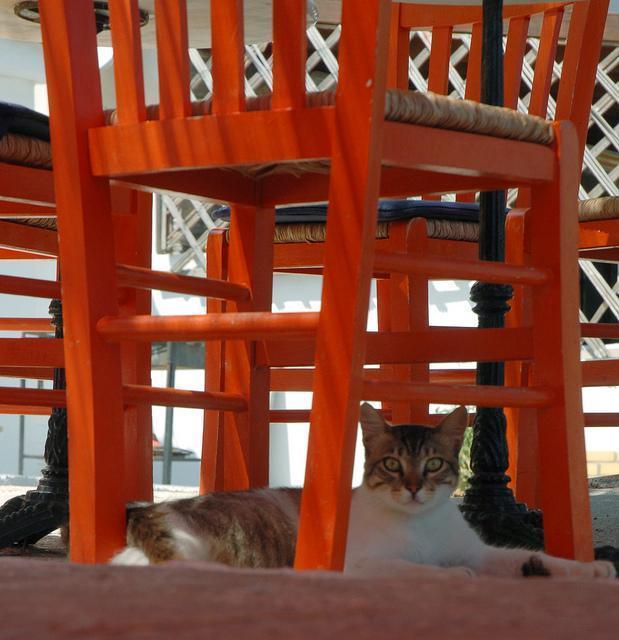How many chairs can you see?
Give a very brief answer. 4. How many people are in the picture?
Give a very brief answer. 0. 